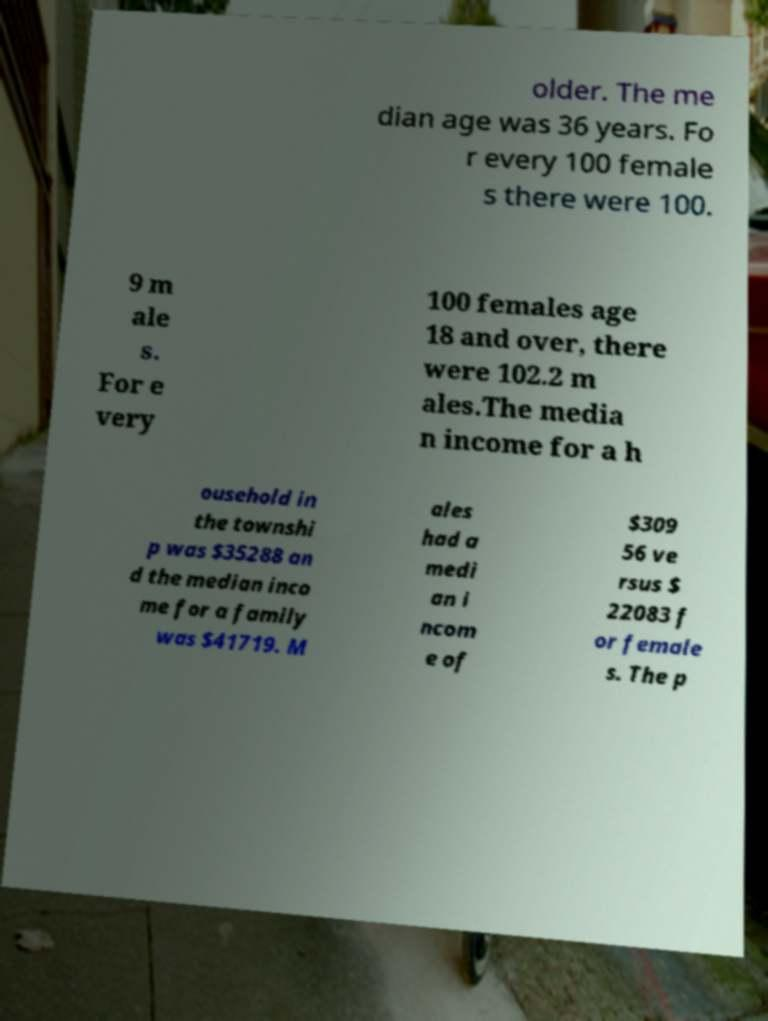There's text embedded in this image that I need extracted. Can you transcribe it verbatim? older. The me dian age was 36 years. Fo r every 100 female s there were 100. 9 m ale s. For e very 100 females age 18 and over, there were 102.2 m ales.The media n income for a h ousehold in the townshi p was $35288 an d the median inco me for a family was $41719. M ales had a medi an i ncom e of $309 56 ve rsus $ 22083 f or female s. The p 